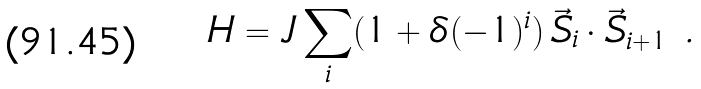<formula> <loc_0><loc_0><loc_500><loc_500>H = J \sum _ { i } ( 1 + \delta ( - 1 ) ^ { i } ) \, { { \vec { S } _ { i } } \cdot { \vec { S } _ { i + 1 } } } \ .</formula> 